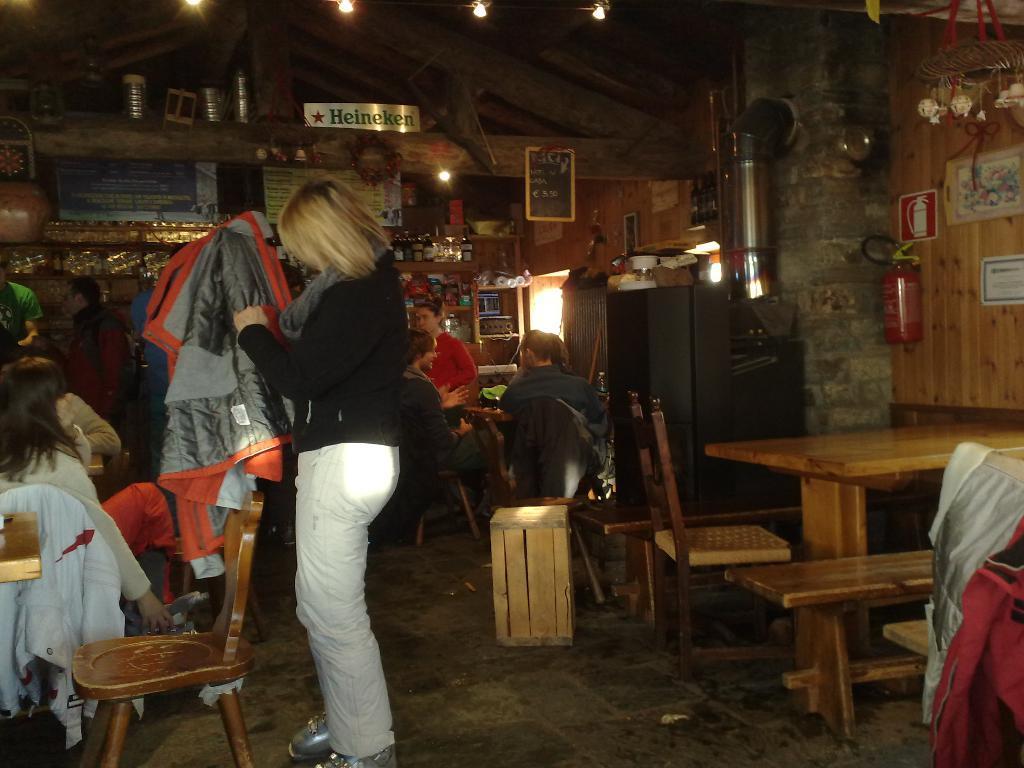Can you describe this image briefly? This picture shows a woman, holding a blanket, in front of a chair. And there are some people sitting in the chairs. In the background there are some people, talking, sitting in the chairs. We can observe some items placed in the shelves and a table. A cylinder is attached to the wall here. 